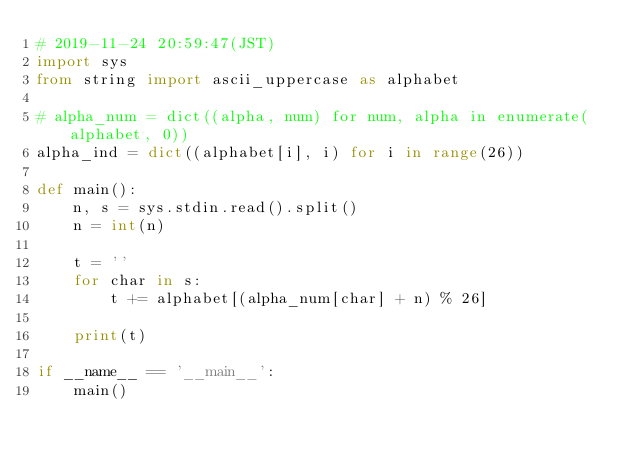<code> <loc_0><loc_0><loc_500><loc_500><_Python_># 2019-11-24 20:59:47(JST)
import sys
from string import ascii_uppercase as alphabet

# alpha_num = dict((alpha, num) for num, alpha in enumerate(alphabet, 0))
alpha_ind = dict((alphabet[i], i) for i in range(26))

def main():
    n, s = sys.stdin.read().split()
    n = int(n)

    t = ''
    for char in s:
        t += alphabet[(alpha_num[char] + n) % 26]
    
    print(t)

if __name__ == '__main__':
    main()
</code> 